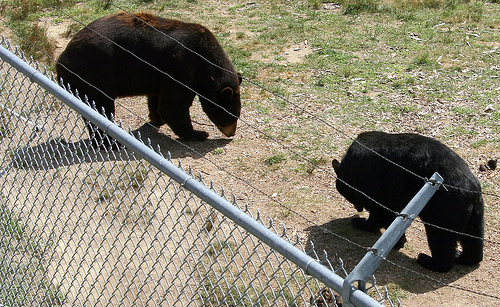What is the environment like where these bears are found? The bears are found in an enclosed environment with a grassy ground cover and a metal fence, which suggests they are not in the wild but rather in a controlled area such as a wildlife reserve, sanctuary, or zoo. Is this type of habitat typical for black bears in the wild? In the wild, American black bears typically inhabit forested regions with a range of vegetation offering them shelter and abundant food sources. While grasslands may be part of their environment, the enclosure is certainly not typical of their natural habitat. 